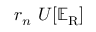Convert formula to latex. <formula><loc_0><loc_0><loc_500><loc_500>r _ { n } U [ \mathbb { E } _ { R } ]</formula> 